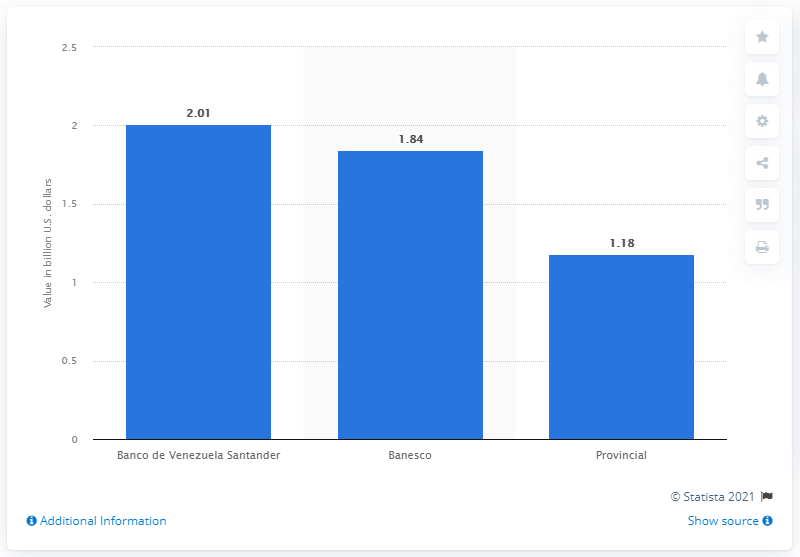Highlight a few significant elements in this photo. The bank with assets exceeding two billion U.S. dollars that led the ranking is Banco de Venezuela Santander. 